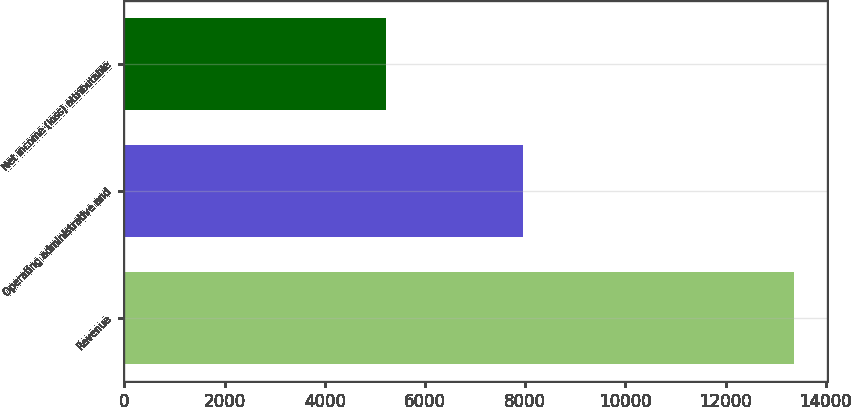<chart> <loc_0><loc_0><loc_500><loc_500><bar_chart><fcel>Revenue<fcel>Operating administrative and<fcel>Net income (loss) attributable<nl><fcel>13359<fcel>7961<fcel>5227<nl></chart> 